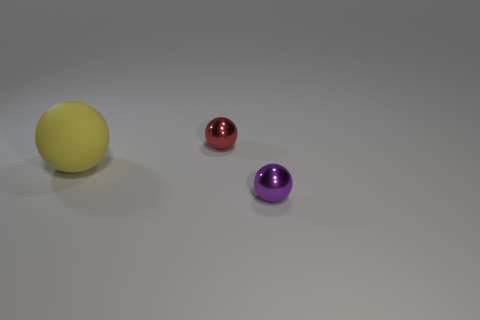What number of cylinders are either tiny metallic objects or large metal things?
Your response must be concise. 0. How big is the ball behind the ball to the left of the tiny red thing?
Your answer should be very brief. Small. Is the color of the large rubber object the same as the tiny metallic ball that is in front of the small red metallic sphere?
Make the answer very short. No. There is a large thing; how many small purple metal balls are right of it?
Keep it short and to the point. 1. Are there fewer large yellow matte things than tiny cyan balls?
Your answer should be very brief. No. What is the size of the object that is in front of the small red thing and right of the yellow rubber ball?
Provide a short and direct response. Small. There is a tiny metallic object that is in front of the small red object; is it the same color as the matte thing?
Ensure brevity in your answer.  No. Is the number of shiny spheres behind the tiny purple thing less than the number of tiny blocks?
Provide a short and direct response. No. Do the big thing and the small red thing have the same material?
Offer a very short reply. No. Are there fewer red objects that are behind the red object than large objects behind the yellow ball?
Your response must be concise. No. 